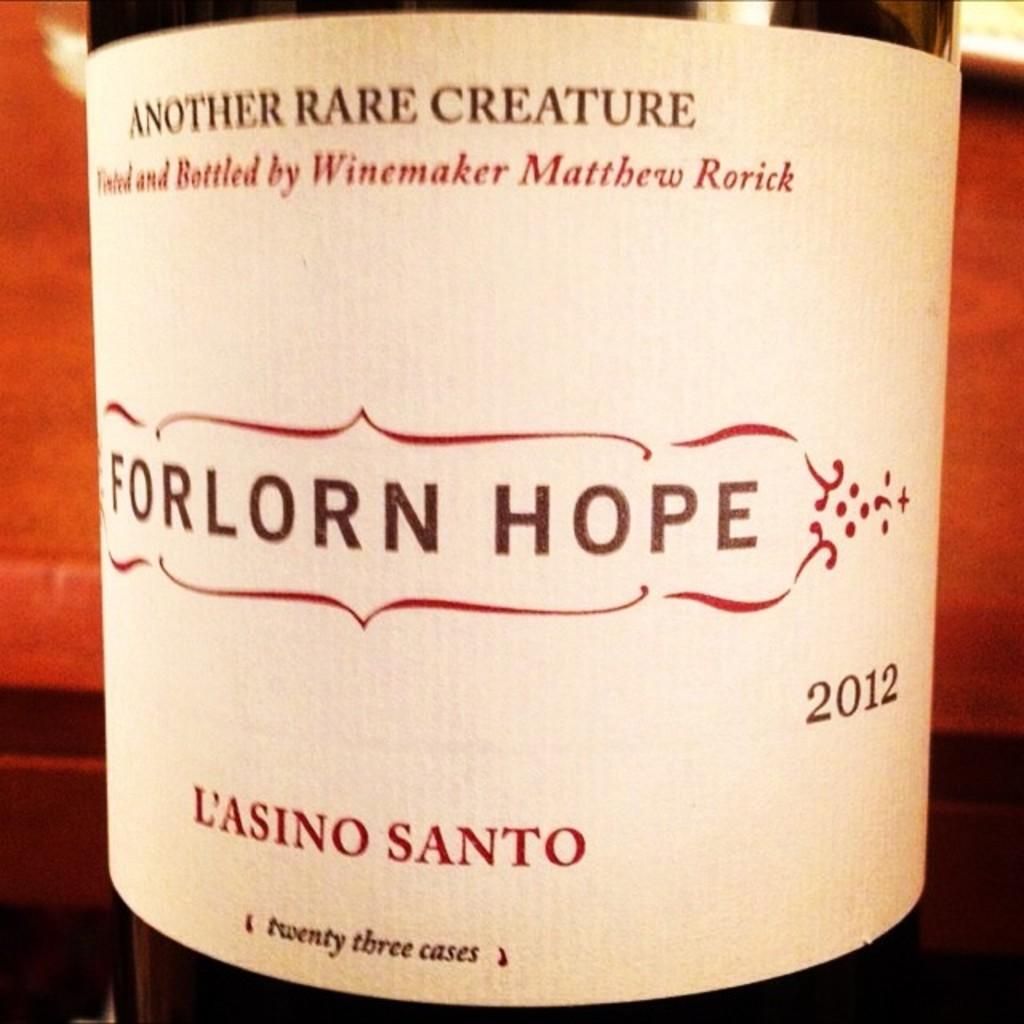What year is this wine?
Offer a very short reply. 2012. What is the name of this wine?
Make the answer very short. Forlorn hope. 